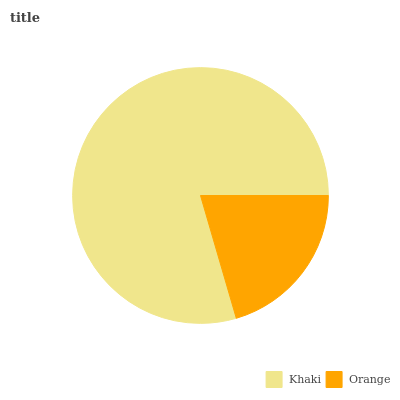Is Orange the minimum?
Answer yes or no. Yes. Is Khaki the maximum?
Answer yes or no. Yes. Is Orange the maximum?
Answer yes or no. No. Is Khaki greater than Orange?
Answer yes or no. Yes. Is Orange less than Khaki?
Answer yes or no. Yes. Is Orange greater than Khaki?
Answer yes or no. No. Is Khaki less than Orange?
Answer yes or no. No. Is Khaki the high median?
Answer yes or no. Yes. Is Orange the low median?
Answer yes or no. Yes. Is Orange the high median?
Answer yes or no. No. Is Khaki the low median?
Answer yes or no. No. 